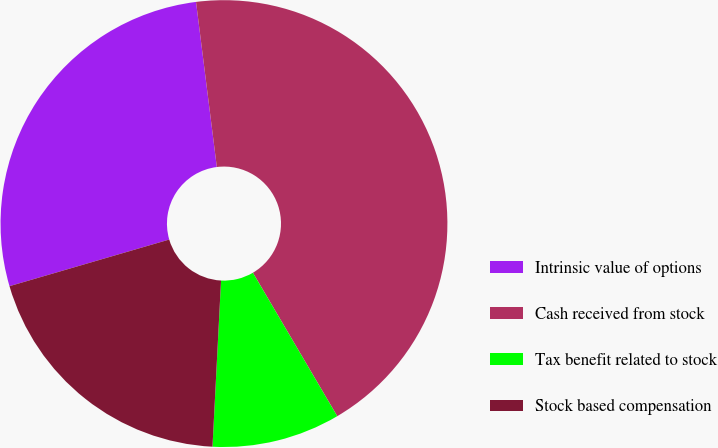Convert chart. <chart><loc_0><loc_0><loc_500><loc_500><pie_chart><fcel>Intrinsic value of options<fcel>Cash received from stock<fcel>Tax benefit related to stock<fcel>Stock based compensation<nl><fcel>27.52%<fcel>43.53%<fcel>9.28%<fcel>19.66%<nl></chart> 